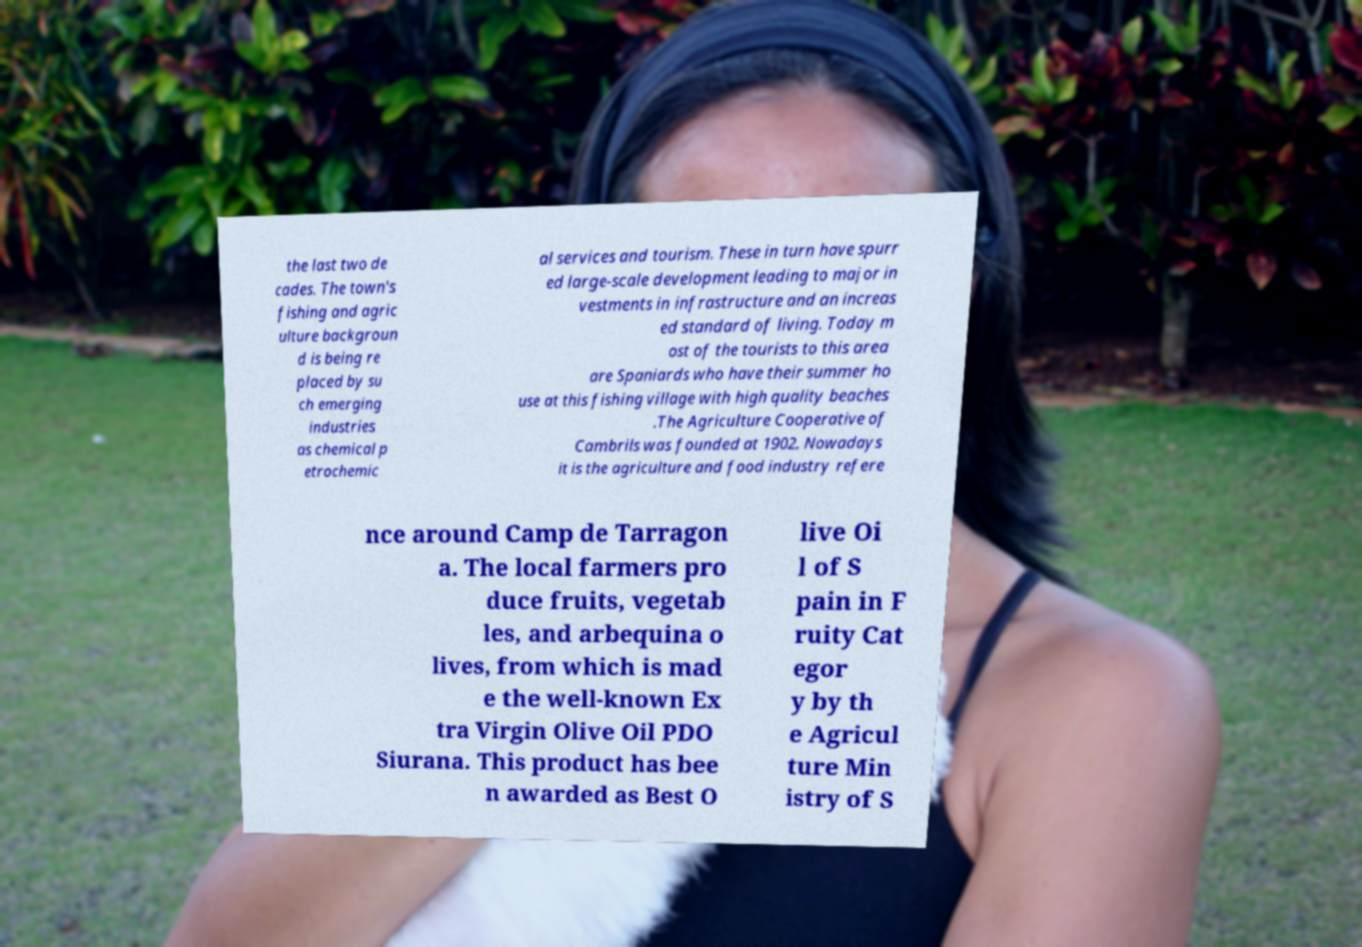Please read and relay the text visible in this image. What does it say? the last two de cades. The town's fishing and agric ulture backgroun d is being re placed by su ch emerging industries as chemical p etrochemic al services and tourism. These in turn have spurr ed large-scale development leading to major in vestments in infrastructure and an increas ed standard of living. Today m ost of the tourists to this area are Spaniards who have their summer ho use at this fishing village with high quality beaches .The Agriculture Cooperative of Cambrils was founded at 1902. Nowadays it is the agriculture and food industry refere nce around Camp de Tarragon a. The local farmers pro duce fruits, vegetab les, and arbequina o lives, from which is mad e the well-known Ex tra Virgin Olive Oil PDO Siurana. This product has bee n awarded as Best O live Oi l of S pain in F ruity Cat egor y by th e Agricul ture Min istry of S 